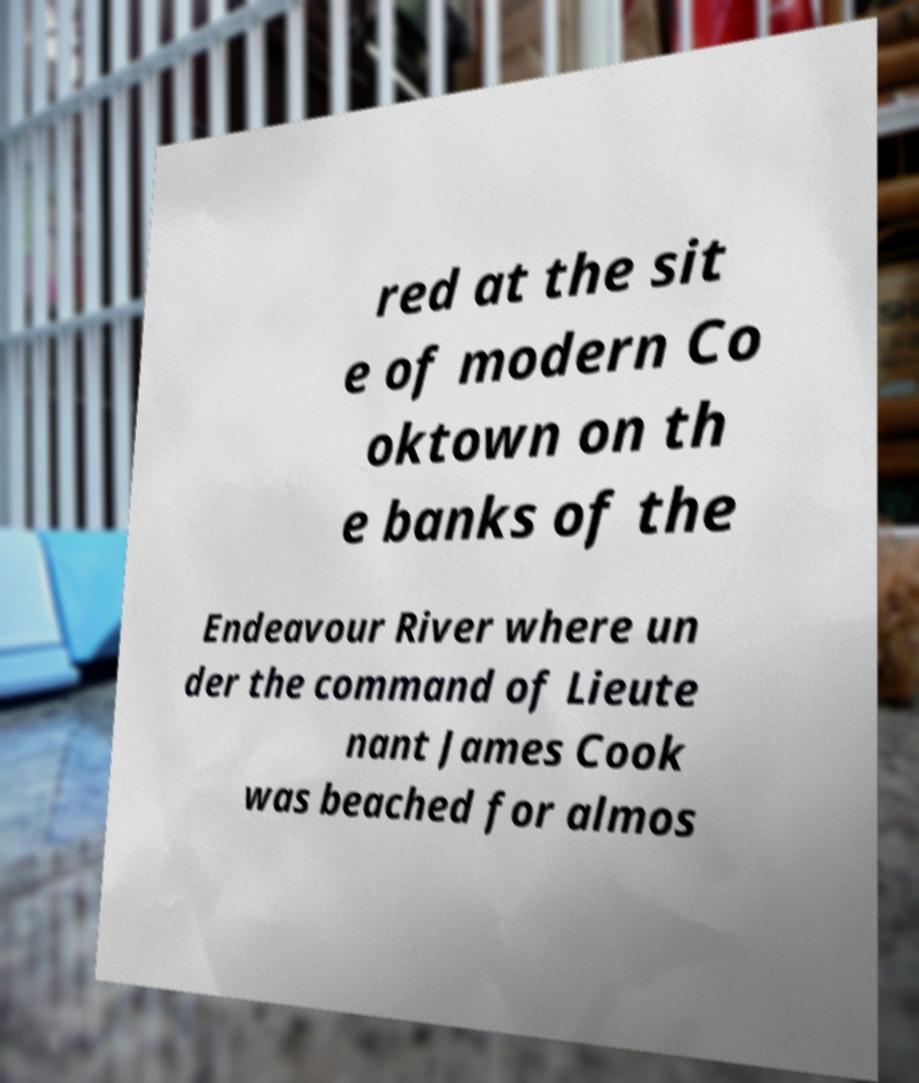There's text embedded in this image that I need extracted. Can you transcribe it verbatim? red at the sit e of modern Co oktown on th e banks of the Endeavour River where un der the command of Lieute nant James Cook was beached for almos 